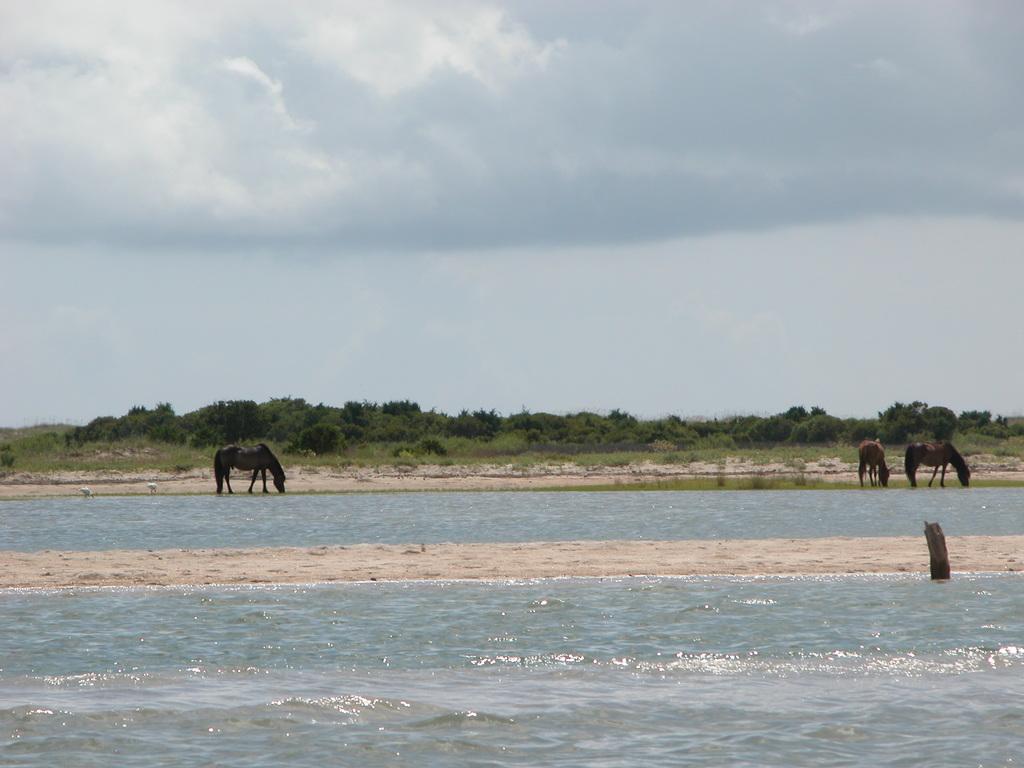Could you give a brief overview of what you see in this image? In this image I can see the water and the sand. To the side of the water I can see few animals which are in black and brown color. In the background I can see the trees, clouds and the sky. 